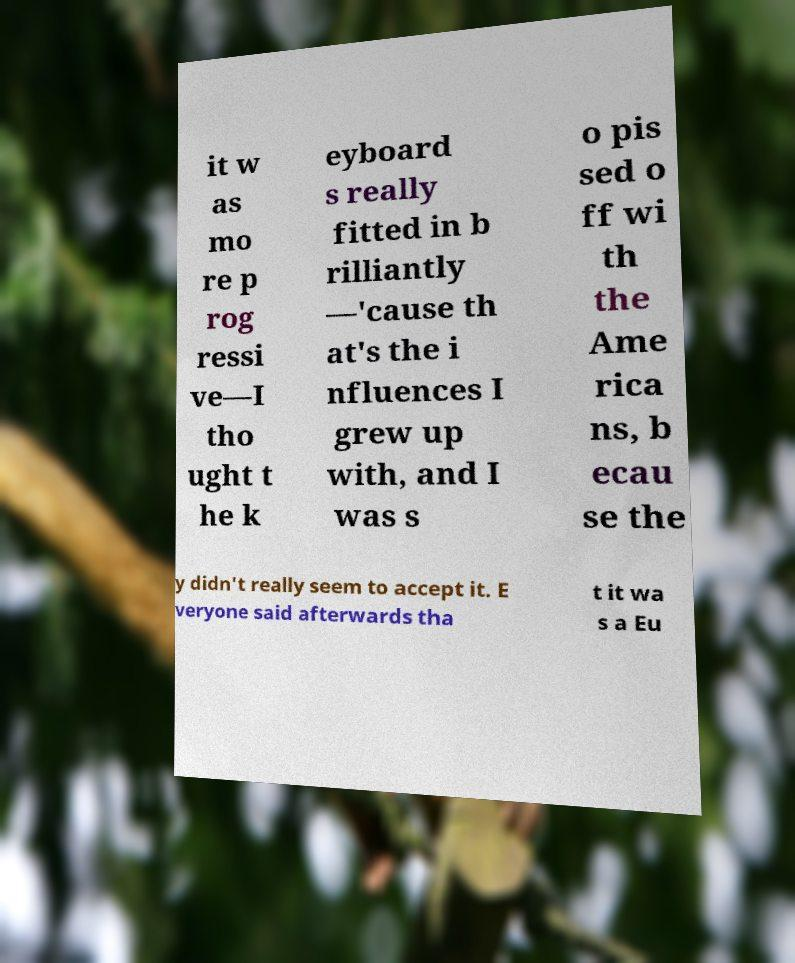Could you extract and type out the text from this image? it w as mo re p rog ressi ve—I tho ught t he k eyboard s really fitted in b rilliantly —'cause th at's the i nfluences I grew up with, and I was s o pis sed o ff wi th the Ame rica ns, b ecau se the y didn't really seem to accept it. E veryone said afterwards tha t it wa s a Eu 